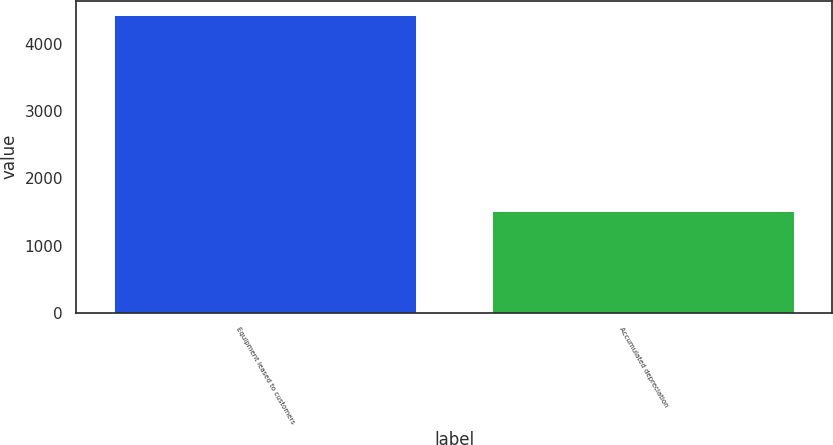Convert chart to OTSL. <chart><loc_0><loc_0><loc_500><loc_500><bar_chart><fcel>Equipment leased to customers<fcel>Accumulated depreciation<nl><fcel>4428<fcel>1513<nl></chart> 